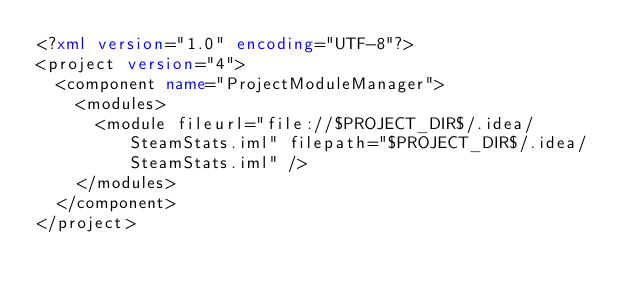Convert code to text. <code><loc_0><loc_0><loc_500><loc_500><_XML_><?xml version="1.0" encoding="UTF-8"?>
<project version="4">
  <component name="ProjectModuleManager">
    <modules>
      <module fileurl="file://$PROJECT_DIR$/.idea/SteamStats.iml" filepath="$PROJECT_DIR$/.idea/SteamStats.iml" />
    </modules>
  </component>
</project></code> 